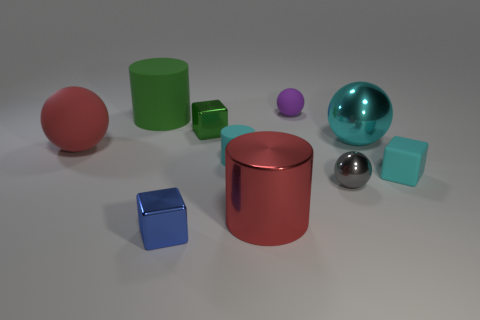How many objects are there in total? Upon inspection, there are a total of nine objects present in the image. 